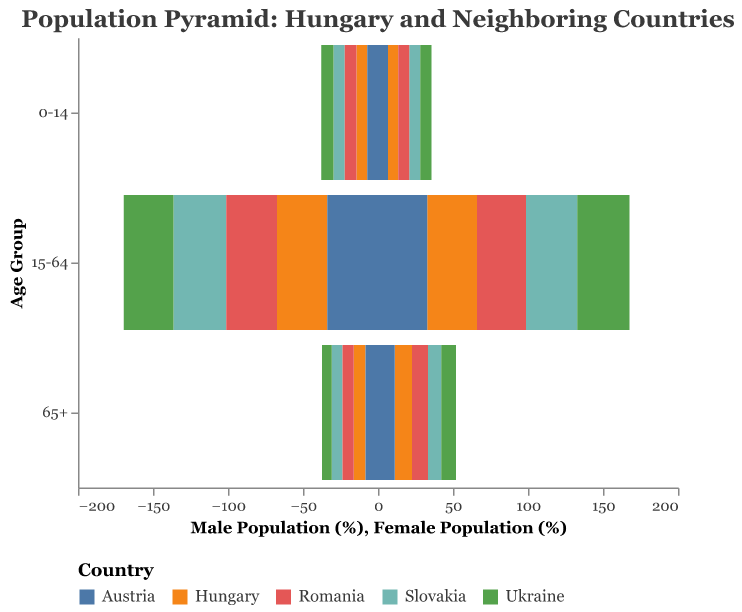What age group has the highest population percentage among males in Hungary? The age group with the highest population percentage among males in Hungary can be identified by looking at the bar with the greatest length on the negative x-axis corresponding to Hungary. The 15-64 age group has a length of 33.5%.
Answer: 15-64 Which country has the highest percentage of females in the 15-64 age group? The highest percentage of females in the 15-64 age group can be identified by the maximum bar length on the positive x-axis for the 15-64 age group. Slovakia has the highest percentage with 34.2%.
Answer: Slovakia What is the difference in the percentage of females aged 65 and older between Hungary and Austria? Look at the lengths of the bars representing females aged 65+ for Hungary and Austria. Hungary has 11.6%, and Austria has 11.1%. Subtract Austria's percentage from Hungary's: 11.6% - 11.1% = 0.5%.
Answer: 0.5% How does the percentage of the male working-age population (15-64) in Austria compare to Romania? Compare the length of the bars representing the 15-64 age group among males for Austria and Romania. Austria has 33.8%, and Romania has 33.9%. Thus, Austria's percentage is slightly lower.
Answer: Lower Which country has the lowest percentage of males in the age group 65 and older? Identify the smallest bar length on the negative x-axis for the 65+ age group across all countries. Ukraine has the lowest percentage with 6.4%.
Answer: Ukraine What is the sum of the percentages of the working-age female population (15-64) in Hungary and Slovakia? Add the percentages of the working-age female population for Hungary and Slovakia from their respective bars. Hungary has 33.1%, and Slovakia has 34.2%. So, the sum is 33.1% + 34.2% = 67.3%.
Answer: 67.3% Which country has the largest difference in population percentage between males and females in the 0-14 age group? For this, we need to calculate the absolute difference between the percentages of males and females in the 0-14 age group for each country and find the maximum. Slovakia has 7.6% - 7.2% = 0.4%, Hungary has 7.2% - 6.8% = 0.4%, Austria has 7.1% - 6.7% = 0.4%, Romania has 7.8% - 7.4% = 0.4%, and Ukraine has 8.1% - 7.6% = 0.5%. Ukraine has the largest difference with 0.5%.
Answer: Ukraine In which country is the female population percentage higher than the male population percentage in the working-age group (15-64)? Compare the percentages of females and males in the 15-64 age group for each country. Only in Ukraine is the female percentage (34.8%) higher than the male percentage (33.2%).
Answer: Ukraine 